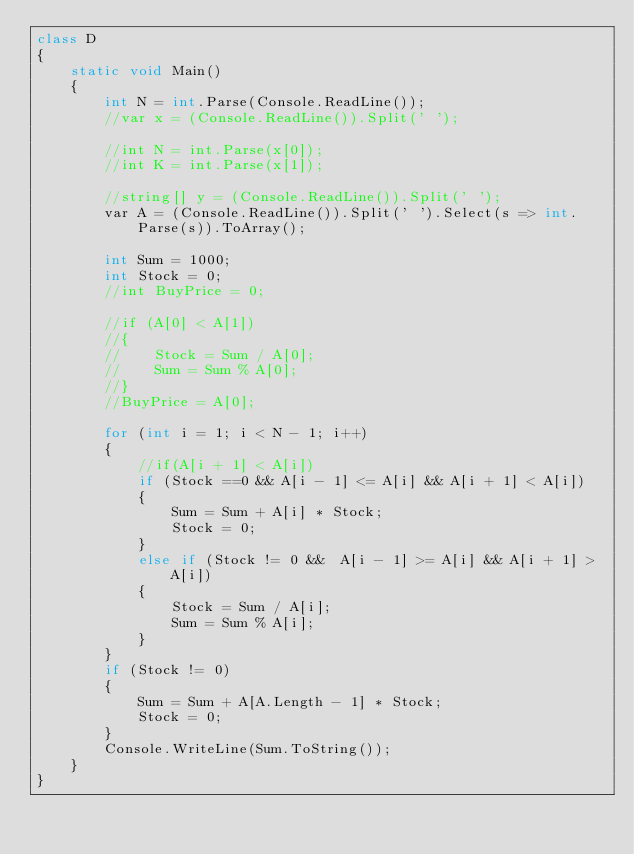Convert code to text. <code><loc_0><loc_0><loc_500><loc_500><_C#_>class D
{
    static void Main()
    {
        int N = int.Parse(Console.ReadLine());
        //var x = (Console.ReadLine()).Split(' ');

        //int N = int.Parse(x[0]);
        //int K = int.Parse(x[1]);

        //string[] y = (Console.ReadLine()).Split(' ');
        var A = (Console.ReadLine()).Split(' ').Select(s => int.Parse(s)).ToArray();

        int Sum = 1000;
        int Stock = 0;
        //int BuyPrice = 0;

        //if (A[0] < A[1])
        //{
        //    Stock = Sum / A[0];
        //    Sum = Sum % A[0];
        //}
        //BuyPrice = A[0];

        for (int i = 1; i < N - 1; i++)
        {
            //if(A[i + 1] < A[i])
            if (Stock ==0 && A[i - 1] <= A[i] && A[i + 1] < A[i])
            {
                Sum = Sum + A[i] * Stock;
                Stock = 0;
            }
            else if (Stock != 0 &&  A[i - 1] >= A[i] && A[i + 1] > A[i])
            {
                Stock = Sum / A[i];
                Sum = Sum % A[i];
            }
        }
        if (Stock != 0)
        {
            Sum = Sum + A[A.Length - 1] * Stock;
            Stock = 0;
        }
        Console.WriteLine(Sum.ToString());
    }
}</code> 